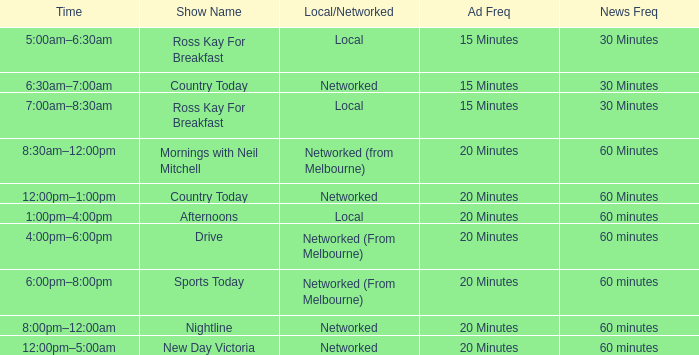When does the advertisement frequency happen every quarter-hour, with a show title named country today? 6:30am–7:00am. 